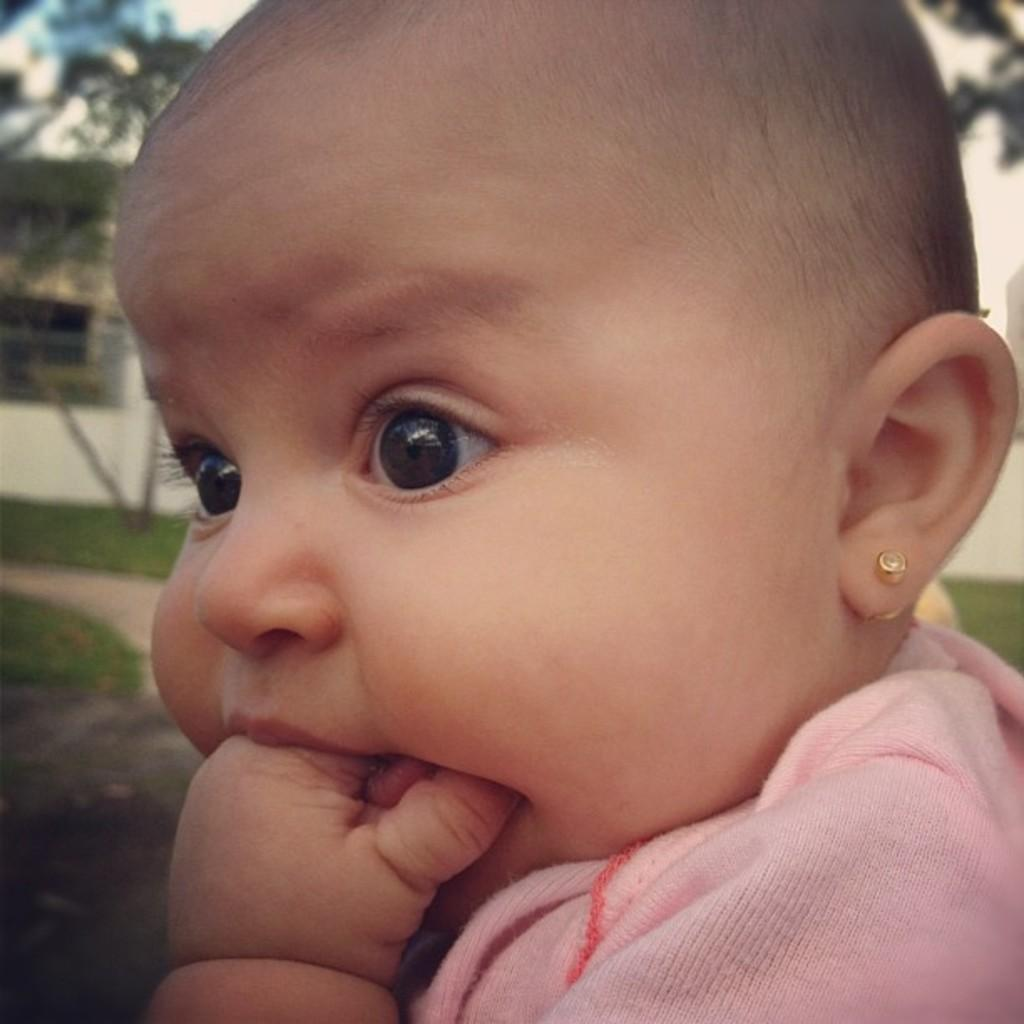What is the main subject in the foreground of the image? There is a baby in the foreground of the image. How is the background of the image depicted? The background of the baby is blurred. Are the baby's friends saying good-bye to them in the image? There is no indication of friends or a good-bye in the image; it only features a baby with a blurred background. 